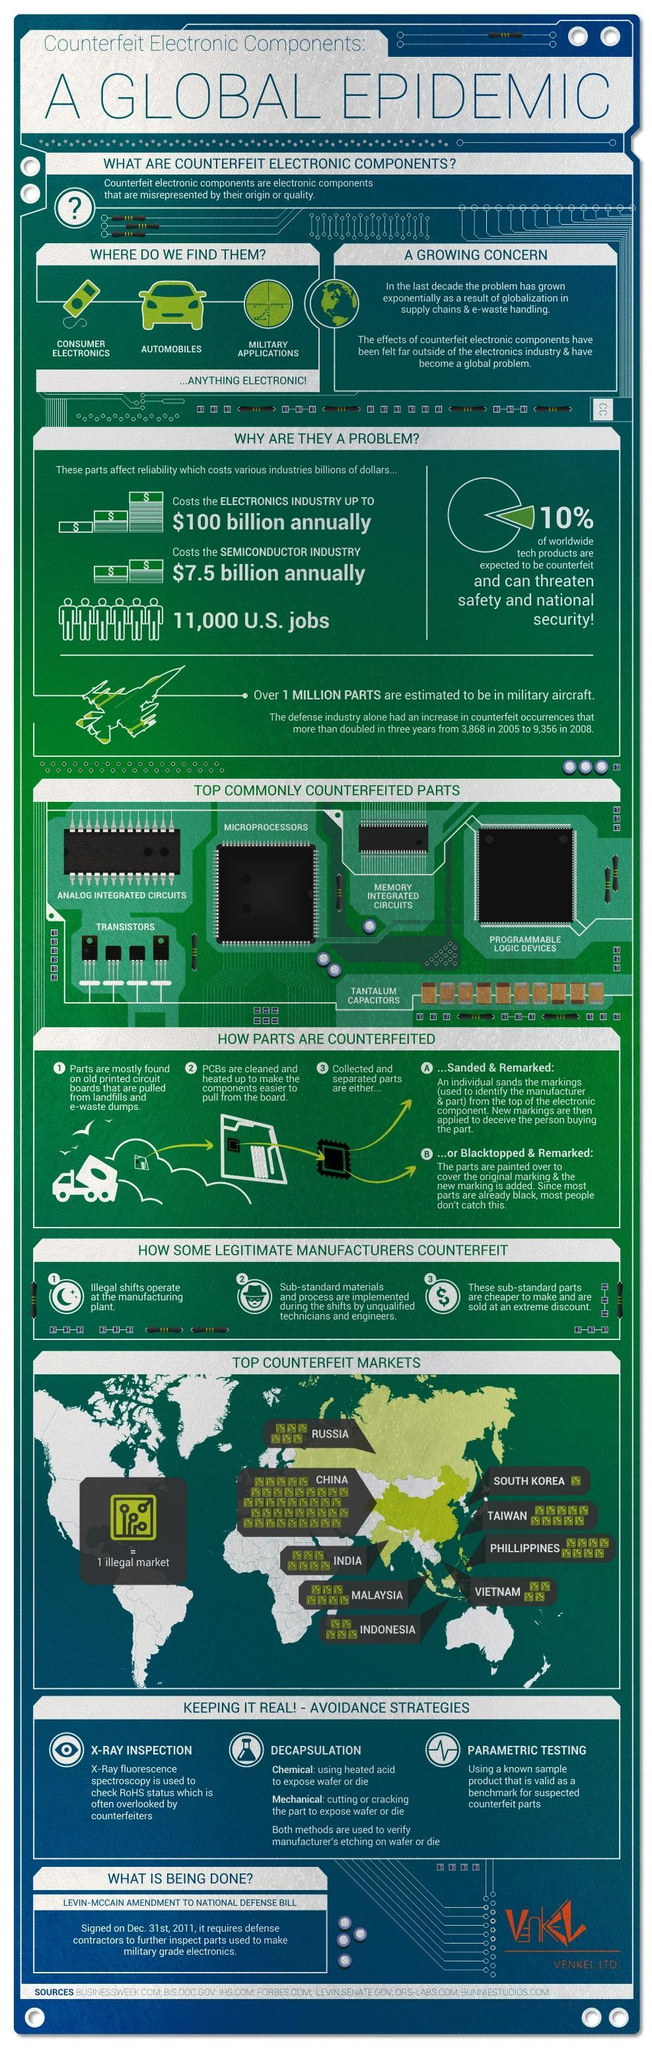Which industry does having counterfeit electronic components affect the second most monetarily?
Answer the question with a short phrase. Semiconductor industry Which country has the second most number of counterfeit markets? Taiwan What is the increase in counterfeit occurrences in the defense industry from 2005 to 2008? 5,488 Which country has the most counterfeit markets? China Which industry does having counterfeit electronic components affect the most monetarily? Electronics industry Which country has the least number of counterfeit markets from the list in the infographic? South Korea 